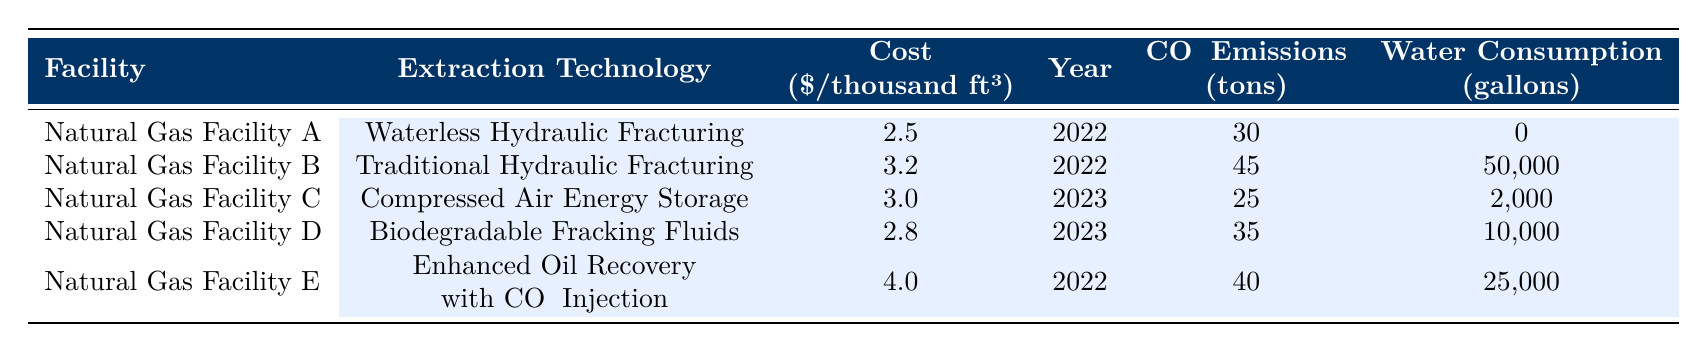What is the extraction technology used at Natural Gas Facility A? The table specifies that Natural Gas Facility A utilizes "Waterless Hydraulic Fracturing" as its extraction technology.
Answer: Waterless Hydraulic Fracturing What is the cost per thousand cubic feet for Enhanced Oil Recovery with CO2 Injection? The table shows that the cost for Enhanced Oil Recovery with CO2 Injection at Natural Gas Facility E is 4.0 dollars per thousand cubic feet.
Answer: 4.0 Which facility has the lowest CO2 emissions, and what is the amount? According to the table, Natural Gas Facility C has the lowest CO2 emissions at 25 tons.
Answer: Natural Gas Facility C, 25 tons What is the total water consumption from all facilities listed in the table? To find the total water consumption, we add the water consumption amounts: 0 + 50000 + 2000 + 10000 + 25000 = 80000 gallons.
Answer: 80000 gallons Is the cost of using Biodegradable Fracking Fluids lower than that of Traditional Hydraulic Fracturing? The table shows that the cost of Biodegradable Fracking Fluids is 2.8 dollars per thousand cubic feet, while Traditional Hydraulic Fracturing costs 3.2 dollars. Since 2.8 is less than 3.2, the statement is true.
Answer: Yes What is the average cost per thousand cubic feet across all facilities? To calculate the average cost, we add all the costs: 2.5 + 3.2 + 3.0 + 2.8 + 4.0 = 15.5 and divide by the number of facilities, which is 5. Thus, the average cost is 15.5 / 5 = 3.1 dollars per thousand cubic feet.
Answer: 3.1 How many facilities have a CO2 emission level greater than 30 tons? In the table, checking each facility: Natural Gas Facility B (45 tons), Natural Gas Facility E (40 tons), and Natural Gas Facility D (35 tons) have emissions greater than 30 tons, so there are 3 such facilities.
Answer: 3 Which extraction technology has the highest cost and what is that cost? Analyzing the costs, Enhanced Oil Recovery with CO2 Injection has the highest cost of 4.0 dollars per thousand cubic feet among all listed technologies.
Answer: Enhanced Oil Recovery with CO2 Injection, 4.0 How much more water does Natural Gas Facility B consume compared to Facility A? Water consumption data shows Facility B consumes 50,000 gallons, while Facility A consumes 0 gallons. The difference is 50,000 - 0 = 50,000 gallons.
Answer: 50,000 gallons 